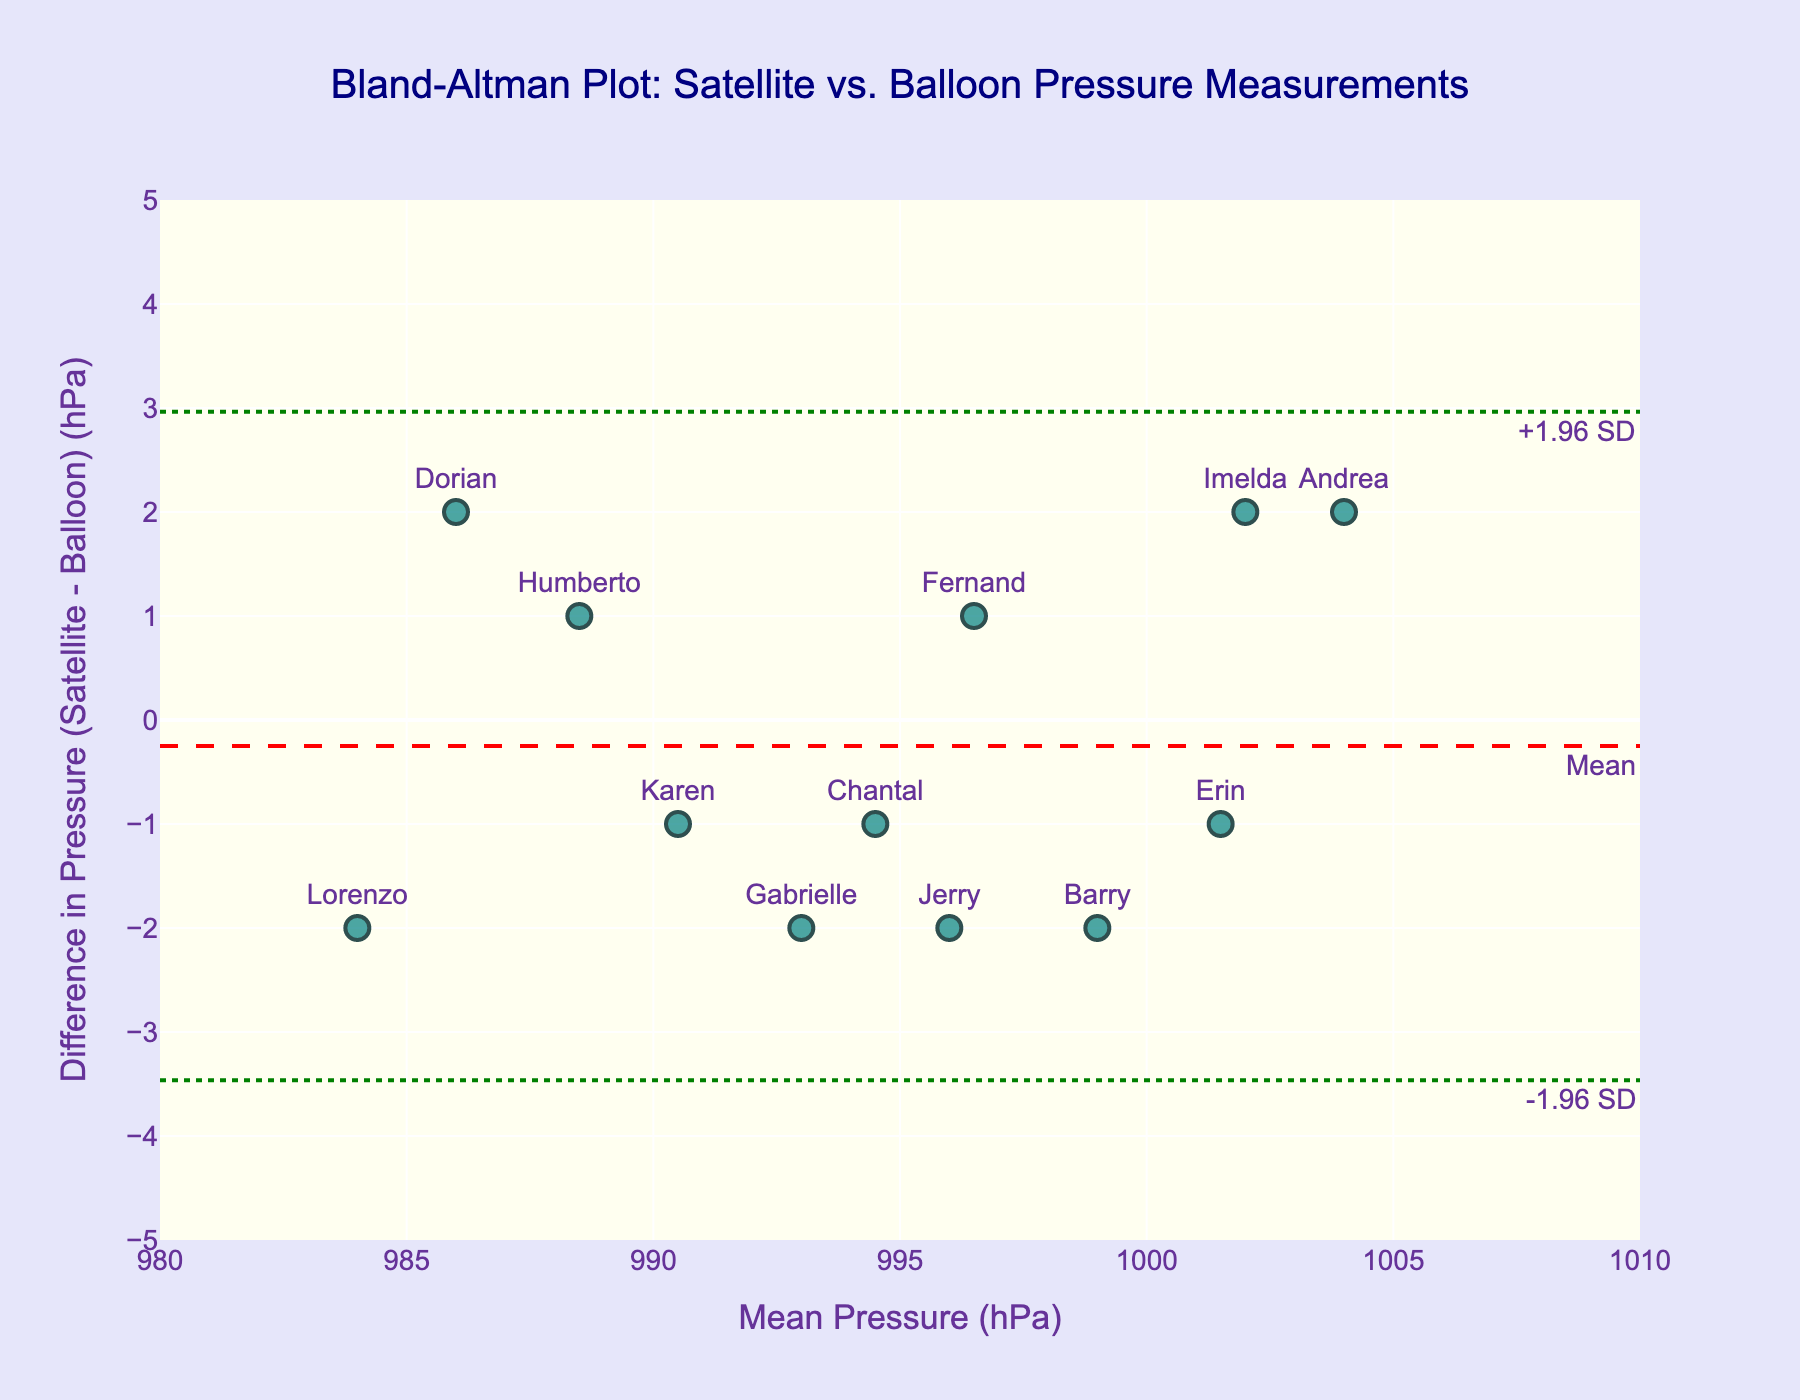What is the title of the plot? The title of the plot is located at the top center of the figure and reads "Bland-Altman Plot: Satellite vs. Balloon Pressure Measurements".
Answer: Bland-Altman Plot: Satellite vs. Balloon Pressure Measurements How many data points are displayed in the figure? Each marker represents a cyclone, and there are 12 cyclones listed in the data. This matches with the number of markers on the plot as each cyclone is labeled.
Answer: 12 What are the units of the x-axis? The x-axis is labeled "Mean Pressure (hPa)", indicating that the units are hectopascals (hPa).
Answer: hectopascals (hPa) What is the range of the y-axis? The y-axis range is shown with tick marks from -5 to 5.
Answer: -5 to 5 What does the red dashed line represent on the plot? The red dashed line is annotated with "Mean" and is located horizontally across the plot, indicating the mean difference in pressures.
Answer: Mean difference Where is the data point for the cyclone "Andrea" located on the plot? The label "Andrea" is at the first data point from the left. It represents a mean pressure of 1004 hPa and a pressure difference of 2 hPa.
Answer: Mean Pressure: 1004 hPa, Difference: 2 hPa Which cyclone has the largest negative pressure difference and what is the value? The label "Barry" is at the bottom right of the plot with a pressure difference of -2. This is the largest negative difference.
Answer: Barry, -2 hPa What are the limits of agreement in the plot? The green dotted lines represent the limits of agreement, annotated as "+1.96 SD" and "-1.96 SD".
Answer: +1.96 SD, -1.96 SD What is the mean difference value shown in the plot, and what does it signify? The mean difference is represented by the red dashed line annotated "Mean" and corresponds to the average difference between the satellite and balloon measurements.
Answer: Mean difference: 0 hPa What is the typical range for the differences in pressure readings based on the plot? The typical range can be deduced from the placement of the green dotted lines, which extend slightly beyond -3 to +3 hPa.
Answer: Approximately -3 to +3 hPa 